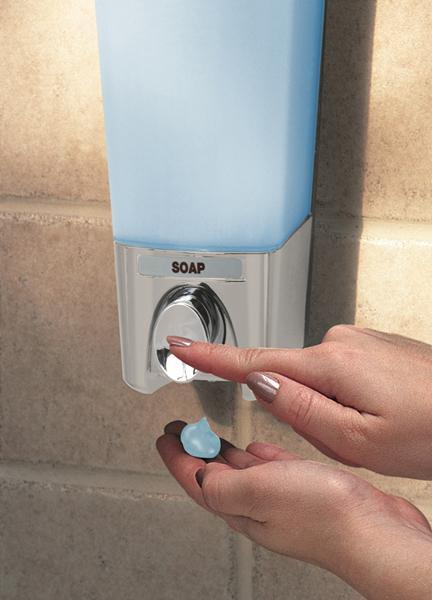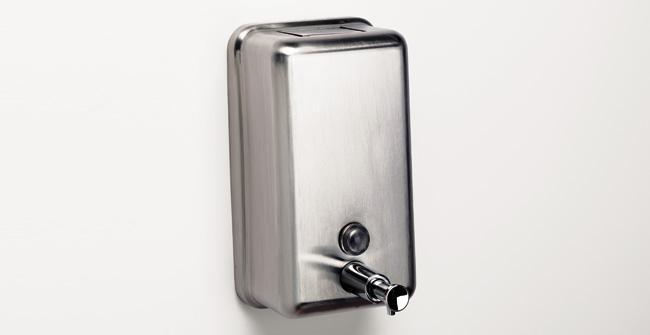The first image is the image on the left, the second image is the image on the right. Given the left and right images, does the statement "A person is pushing the dispenser in the image on the left." hold true? Answer yes or no. Yes. The first image is the image on the left, the second image is the image on the right. For the images shown, is this caption "A restroom interior contains a counter with at least three identical white sinks." true? Answer yes or no. No. 